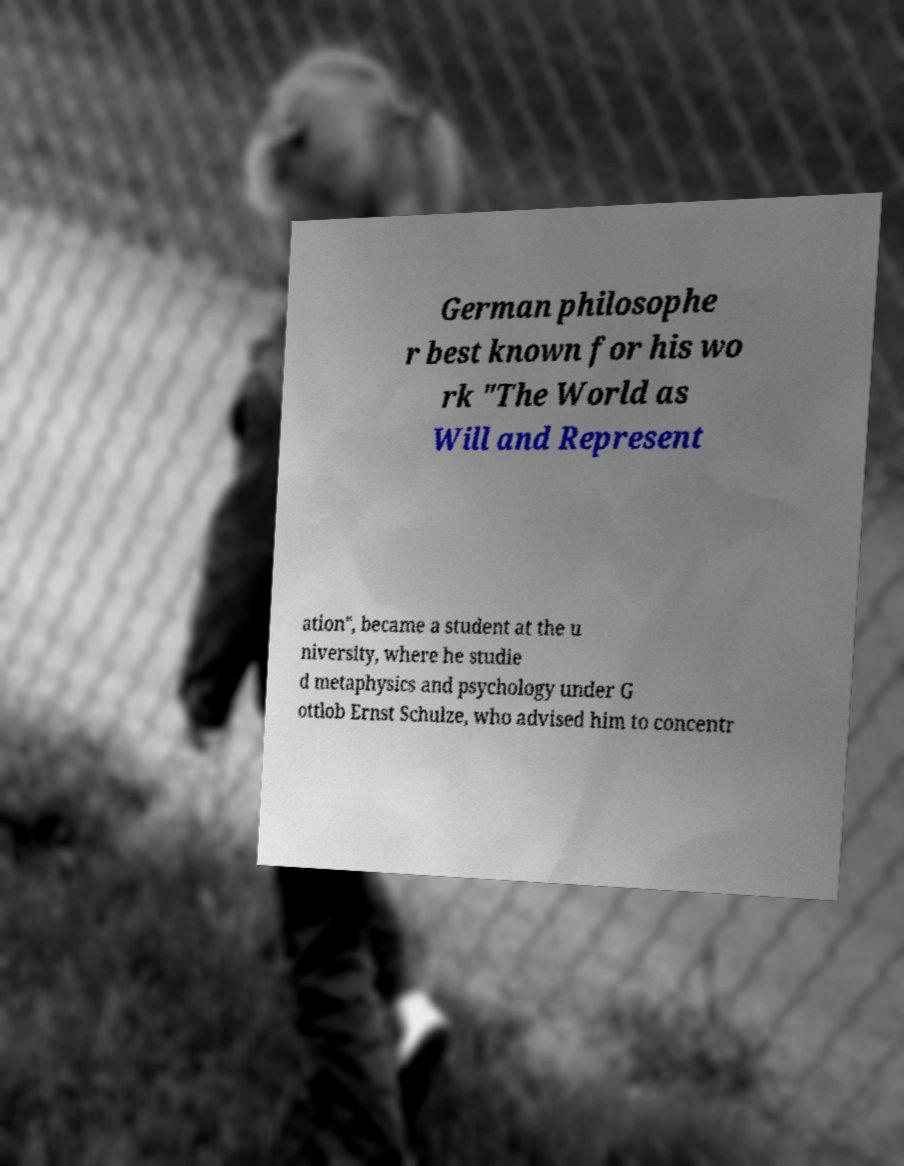Can you read and provide the text displayed in the image?This photo seems to have some interesting text. Can you extract and type it out for me? German philosophe r best known for his wo rk "The World as Will and Represent ation", became a student at the u niversity, where he studie d metaphysics and psychology under G ottlob Ernst Schulze, who advised him to concentr 